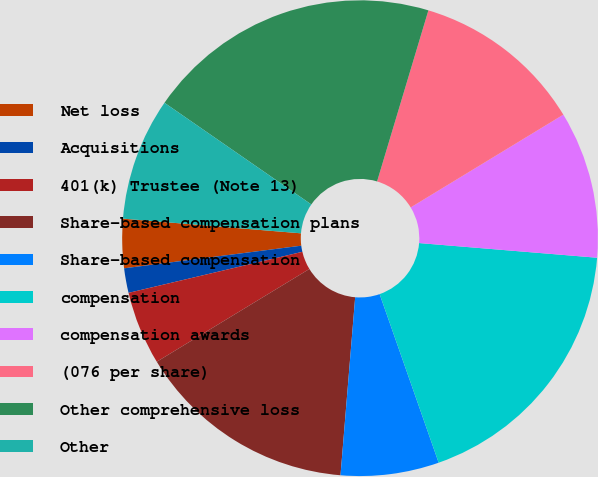Convert chart to OTSL. <chart><loc_0><loc_0><loc_500><loc_500><pie_chart><fcel>Net loss<fcel>Acquisitions<fcel>401(k) Trustee (Note 13)<fcel>Share-based compensation plans<fcel>Share-based compensation<fcel>compensation<fcel>compensation awards<fcel>(076 per share)<fcel>Other comprehensive loss<fcel>Other<nl><fcel>3.33%<fcel>1.67%<fcel>5.0%<fcel>15.0%<fcel>6.67%<fcel>18.33%<fcel>10.0%<fcel>11.67%<fcel>20.0%<fcel>8.33%<nl></chart> 